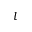<formula> <loc_0><loc_0><loc_500><loc_500>l</formula> 